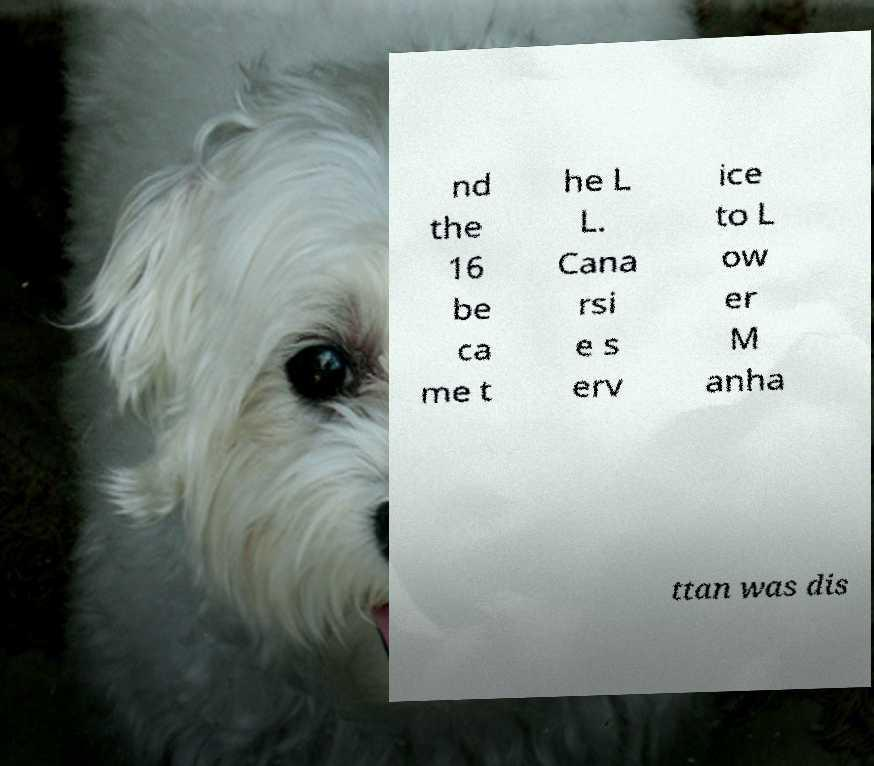Can you read and provide the text displayed in the image?This photo seems to have some interesting text. Can you extract and type it out for me? nd the 16 be ca me t he L L. Cana rsi e s erv ice to L ow er M anha ttan was dis 